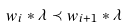<formula> <loc_0><loc_0><loc_500><loc_500>w _ { i } \ast \lambda \prec w _ { i + 1 } \ast \lambda</formula> 